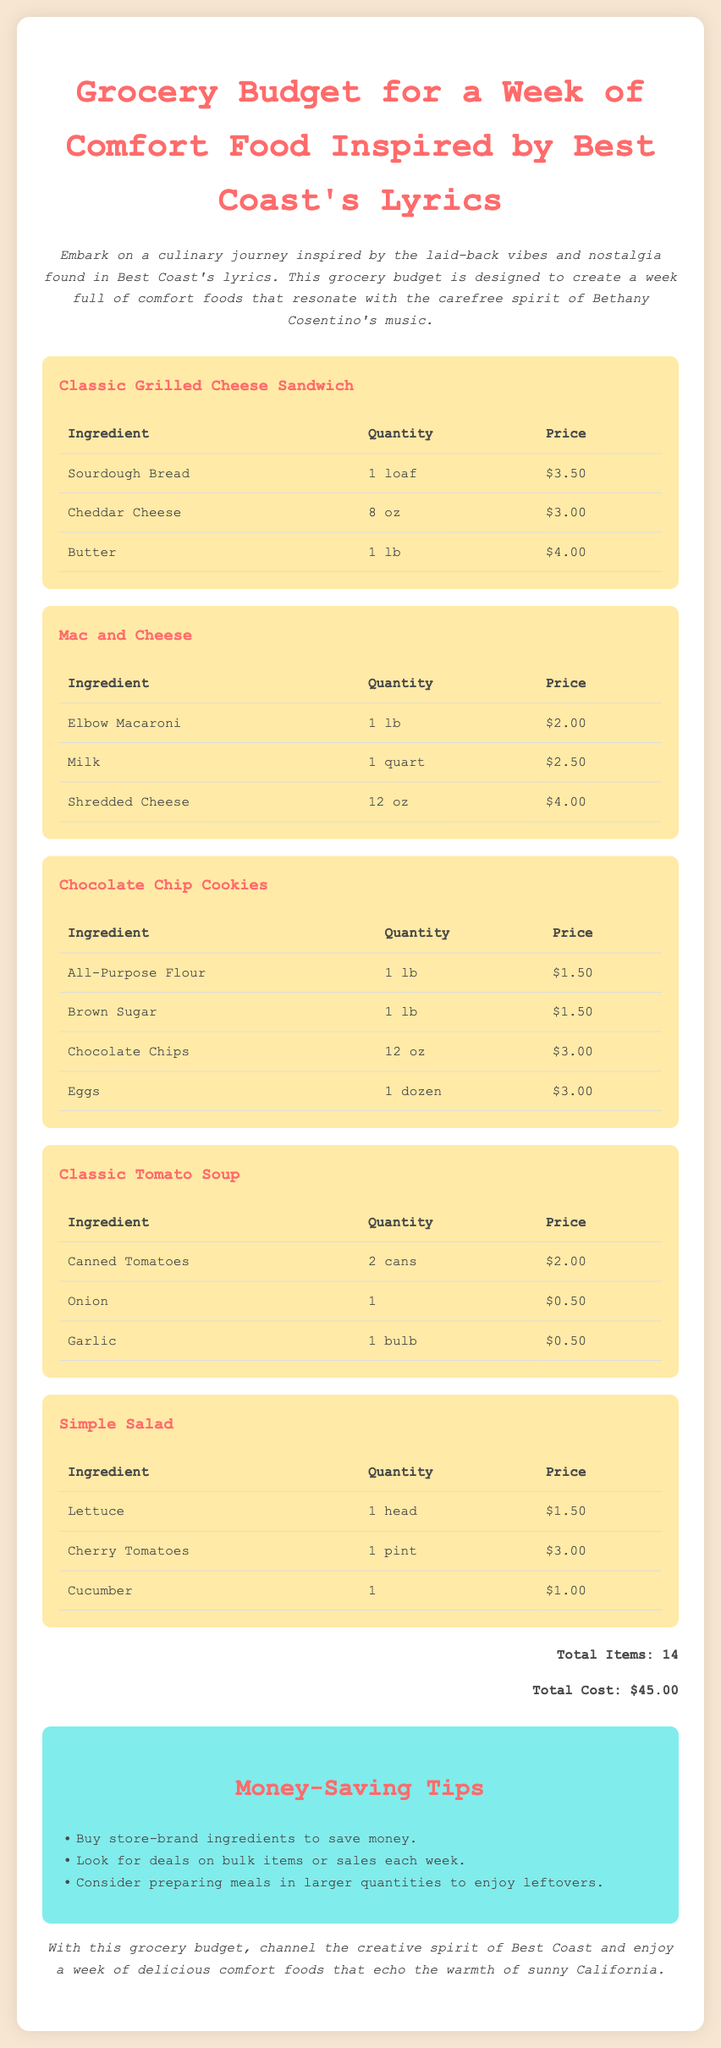What is the total cost? The total cost is the sum of all the individual item prices listed in the document, which equals $45.00.
Answer: $45.00 How many ingredients are listed? The total number of ingredients mentioned across all comfort food dishes is 14.
Answer: 14 What ingredient is used for the Classic Grilled Cheese Sandwich? One of the ingredients listed for the Classic Grilled Cheese Sandwich is Sourdough Bread.
Answer: Sourdough Bread What is the price of Cheddar Cheese? The price of Cheddar Cheese is found in the table for the Classic Grilled Cheese Sandwich, which is $3.00.
Answer: $3.00 Which comfort food uses Elbow Macaroni? The comfort food that includes Elbow Macaroni is identified as Mac and Cheese.
Answer: Mac and Cheese What is a suggested money-saving tip? A suggested money-saving tip is to buy store-brand ingredients to save money.
Answer: Buy store-brand ingredients What is the quantity of Canned Tomatoes needed for the Classic Tomato Soup? The quantity of Canned Tomatoes required for the Classic Tomato Soup is 2 cans.
Answer: 2 cans Which ingredient is included in the Simple Salad? One of the ingredients listed in the Simple Salad is Lettuce.
Answer: Lettuce What is the total number of comfort food dishes listed? The document lists a total of 5 comfort food dishes.
Answer: 5 